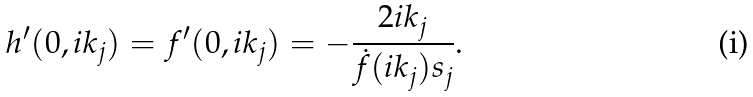<formula> <loc_0><loc_0><loc_500><loc_500>h ^ { \prime } ( 0 , i k _ { j } ) = f ^ { \prime } ( 0 , i k _ { j } ) = - \frac { 2 i k _ { j } } { \dot { f } ( i k _ { j } ) s _ { j } } .</formula> 